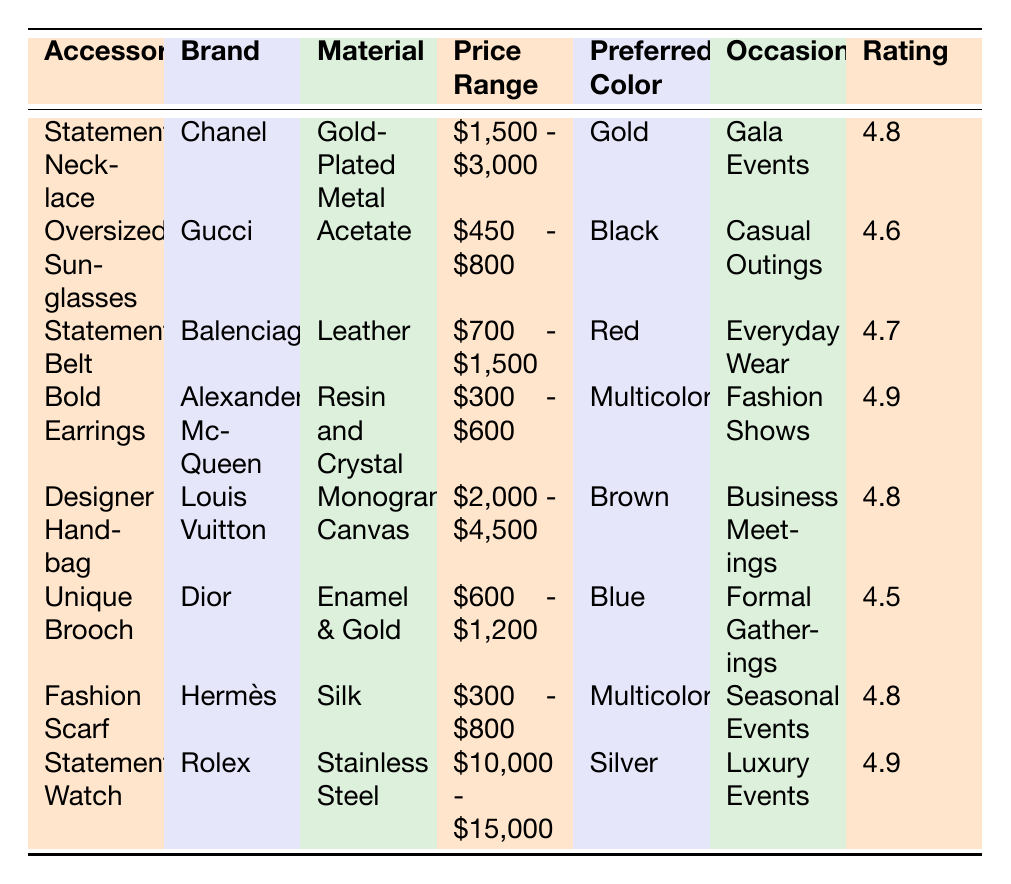What is the highest customer rating among the accessories? The table lists customer ratings for the accessories, with the highest rating being 4.9 for both the Bold Earrings by Alexander McQueen and the Statement Watch by Rolex.
Answer: 4.9 Which accessory is the most expensive? The price range for each accessory is listed in the table. The Statement Watch by Rolex has the highest price range of $10,000 - $15,000.
Answer: Statement Watch What color is preferred for the Unique Brooch? The table specifies that the preferred color for the Unique Brooch by Dior is Blue.
Answer: Blue What is the average price range of the accessories listed? To find the average price range, calculate the midpoints of each price range: (2250 + 625 + 1150 + 450 + 3250 + 900 + 550 + 12500) / 8 = 2244.75, which gives an average range around $2,244.75.
Answer: Approximately $2,244.75 Is the Statement Necklace rated higher than the Unique Brooch? The customer rating for the Statement Necklace is 4.8, while the rating for the Unique Brooch is 4.5, making it rated higher.
Answer: Yes What material is used in the Designer Handbag? The table indicates that the material used for the Designer Handbag by Louis Vuitton is Monogram Canvas.
Answer: Monogram Canvas Which occasion is the Bold Earrings designed for? The table states that the Bold Earrings by Alexander McQueen are intended for Fashion Shows.
Answer: Fashion Shows How many accessories have a customer rating of 4.8 or higher? By analyzing the ratings, there are five accessories with ratings of 4.8 or higher: Statement Necklace, Designer Handbag, Fashion Scarf, Bold Earrings, and Statement Watch.
Answer: Five What is the price range of the most affordable accessory? The Bold Earrings have the lowest price range, which is $300 - $600.
Answer: $300 - $600 Are the Oversized Sunglasses suitable for formal gatherings? The table lists the occasion for the Oversized Sunglasses as Casual Outings, which suggests they are not suitable for formal gatherings.
Answer: No 